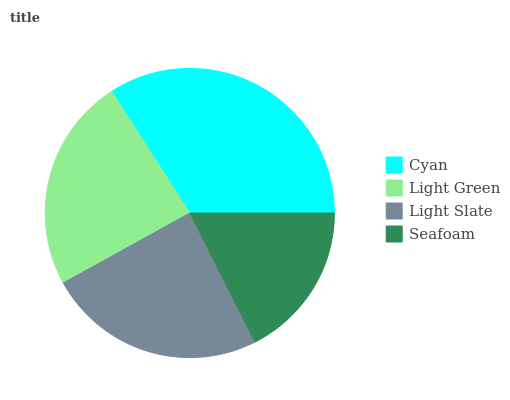Is Seafoam the minimum?
Answer yes or no. Yes. Is Cyan the maximum?
Answer yes or no. Yes. Is Light Green the minimum?
Answer yes or no. No. Is Light Green the maximum?
Answer yes or no. No. Is Cyan greater than Light Green?
Answer yes or no. Yes. Is Light Green less than Cyan?
Answer yes or no. Yes. Is Light Green greater than Cyan?
Answer yes or no. No. Is Cyan less than Light Green?
Answer yes or no. No. Is Light Slate the high median?
Answer yes or no. Yes. Is Light Green the low median?
Answer yes or no. Yes. Is Seafoam the high median?
Answer yes or no. No. Is Cyan the low median?
Answer yes or no. No. 